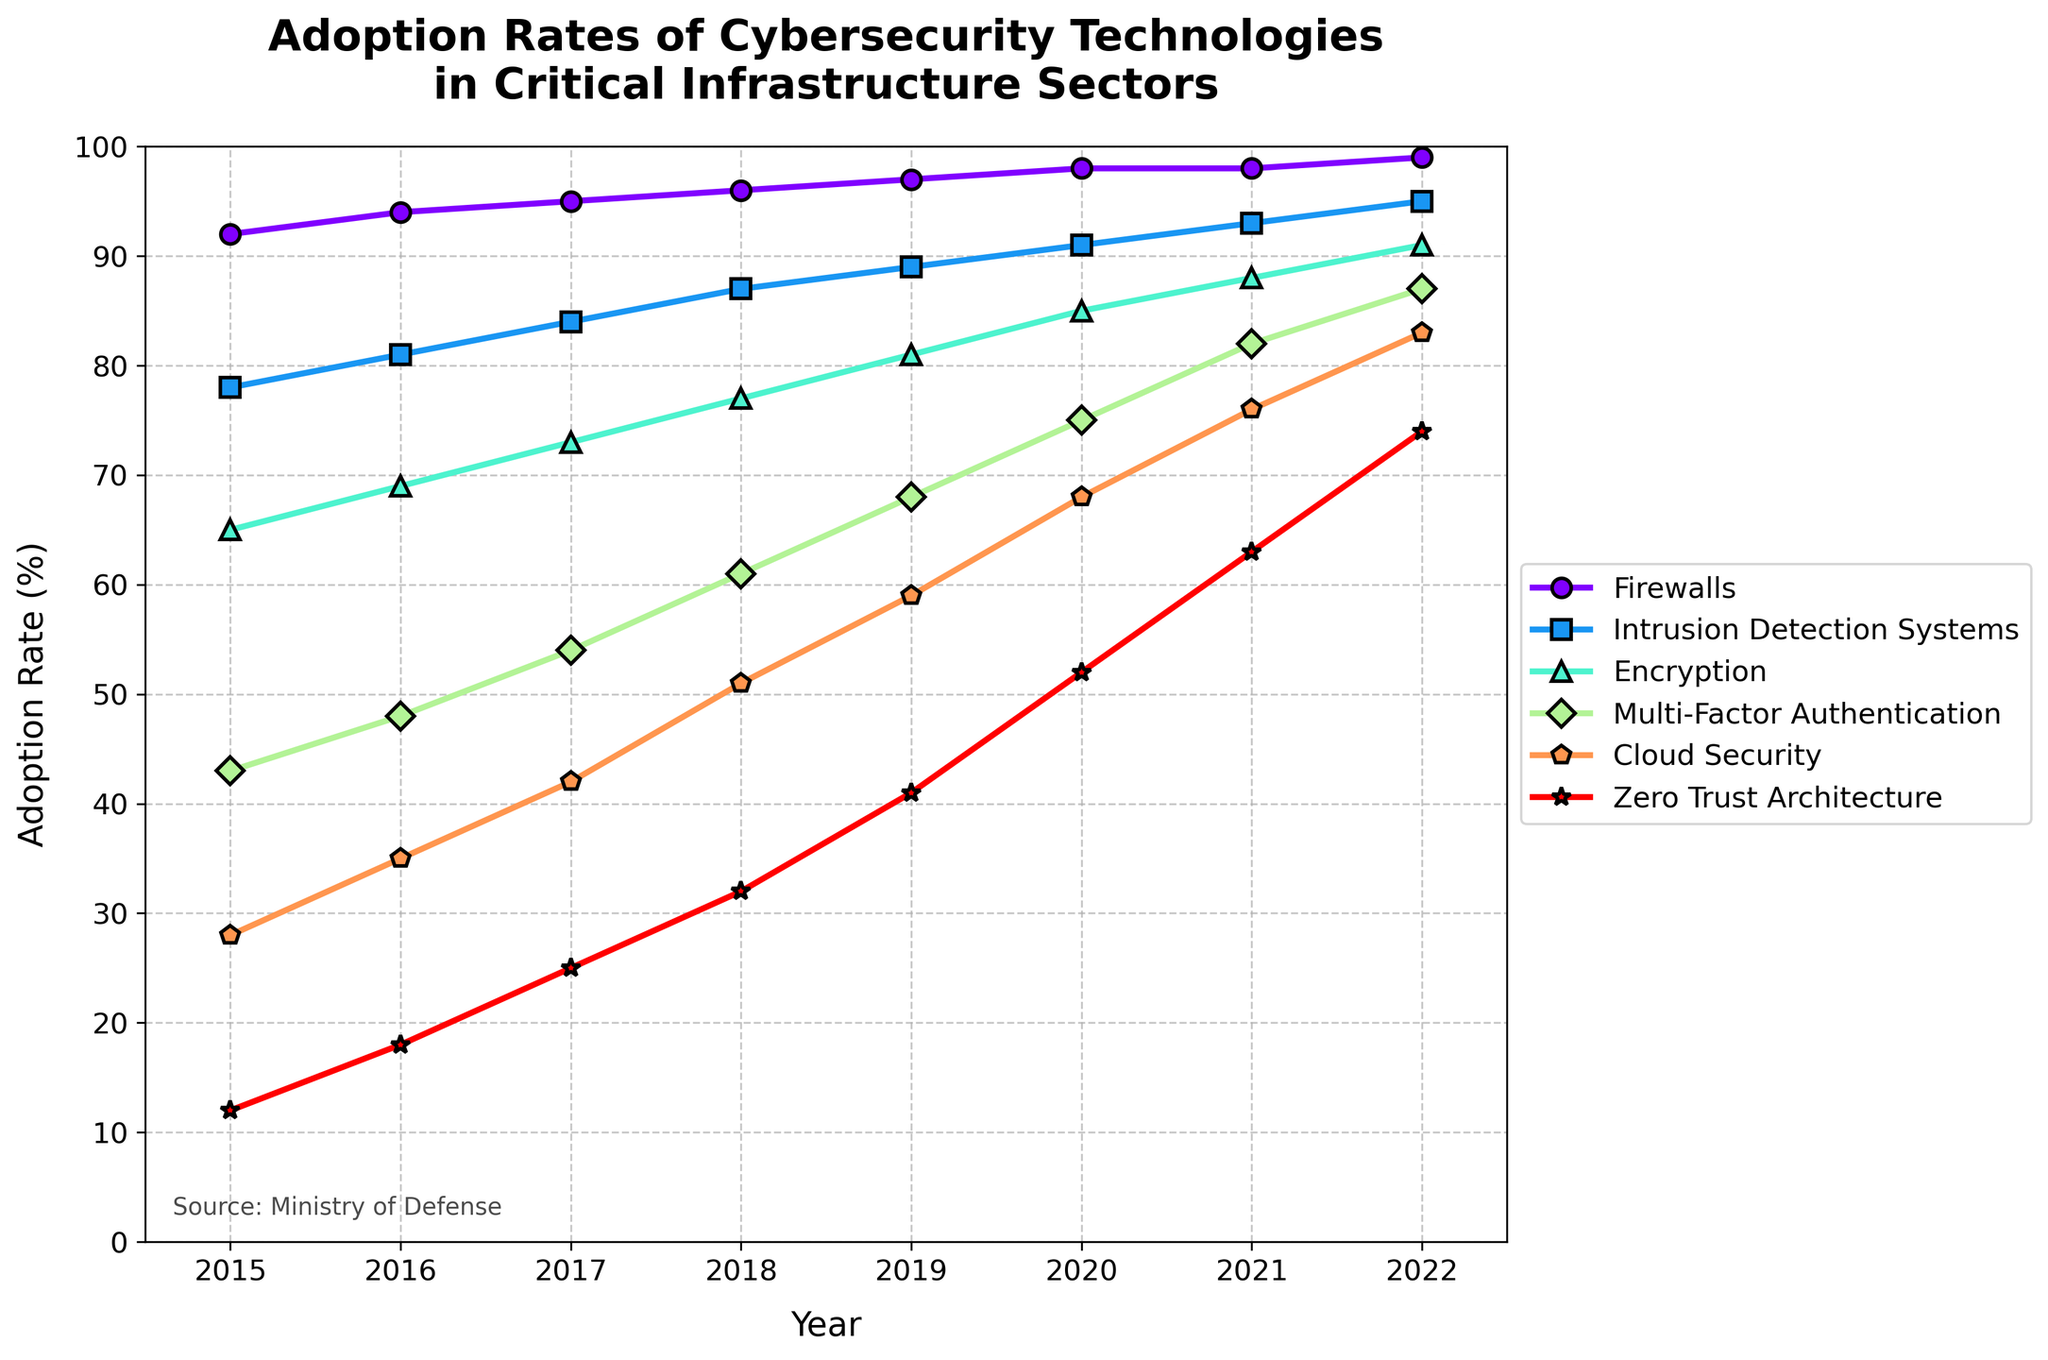What cybersecurity technology had the highest adoption rate in 2022? To determine the cybersecurity technology with the highest adoption rate in 2022, refer to the end of each line representing a technology in the figure for that year. The line representing Firewalls reaches the 99% mark, the highest adoption rate among all technologies.
Answer: Firewalls Which cybersecurity technology showed the most significant growth in adoption from 2015 to 2022? To find the technology with the most significant growth, we need to compare the adoption rates in 2015 and 2022 for all technologies and calculate the difference. Zero Trust Architecture had an adoption rate of 12% in 2015 and 74% in 2022, resulting in a growth of 62 percentage points, which is the highest.
Answer: Zero Trust Architecture What was the adoption rate of Multi-Factor Authentication in 2018 and did it surpass 60% before 2018? For the adoption rate in 2018, refer to the position of Multi-Factor Authentication's line at the 2018 mark, which is at 61%. To check if it surpassed 60% before 2018, observe the line before this mark. In 2017, the adoption rate was 54%, so it did not surpass 60% before 2018.
Answer: 61%, No Between which two years did Intrusion Detection Systems show the largest annual increase in adoption rates? To determine the largest annual increase, inspect the steepness of the Intrusion Detection Systems' line between each pair of consecutive years. The line is steepest between 2021 and 2022, rising from 93% to 95%, showing a 2% increase.
Answer: 2021-2022 How does the adoption trend of Cloud Security compare to Firewalls over the years? Comparing the trends of Cloud Security and Firewalls involves examining the slopes of their lines. Both show an increasing trend, but Firewalls started at a higher rate and remained consistently ahead, while Cloud Security showed a substantial but slower increase from 28% to 83%. Firewalls reached near-saturation levels by 2022.
Answer: Cloud Security increased steadily but slower compared to Firewalls What was the combined adoption rate of Encryption and Zero Trust Architecture in 2020? To find the combined rate, add the adoption rates of Encryption (85%) and Zero Trust Architecture (52%) in 2020, giving a sum of 137%.
Answer: 137% Which technology had the smallest increase in adoption rate between 2015 and 2017? Calculate the difference in adoption rates for each technology between 2015 and 2017. Firewalls increased from 92% to 95%, a 3% increase, which is the smallest compared to others.
Answer: Firewalls What percentage increase in adoption did Multi-Factor Authentication see from 2016 to 2017? The adoption rate of Multi-Factor Authentication in 2016 was 48% and rose to 54% in 2017. The percentage increase can be calculated as ((54 - 48) / 48) * 100 = 12.5%.
Answer: 12.5% Which two technologies had the closest adoption rates in 2019? Compare the rates for all pairs in 2019. Encryption (81%) and Intrusion Detection Systems (89%) are closest amongst given pairs. The difference between them is 8%, smallest amongst other pairs.
Answer: Encryption and Intrusion Detection Systems In which year did Encryption first surpass a 70% adoption rate? Observe the Encryption line and see where it first crosses the 70% mark. In 2017, Encryption adoption is 73%, surpassing 70% for the first time.
Answer: 2017 